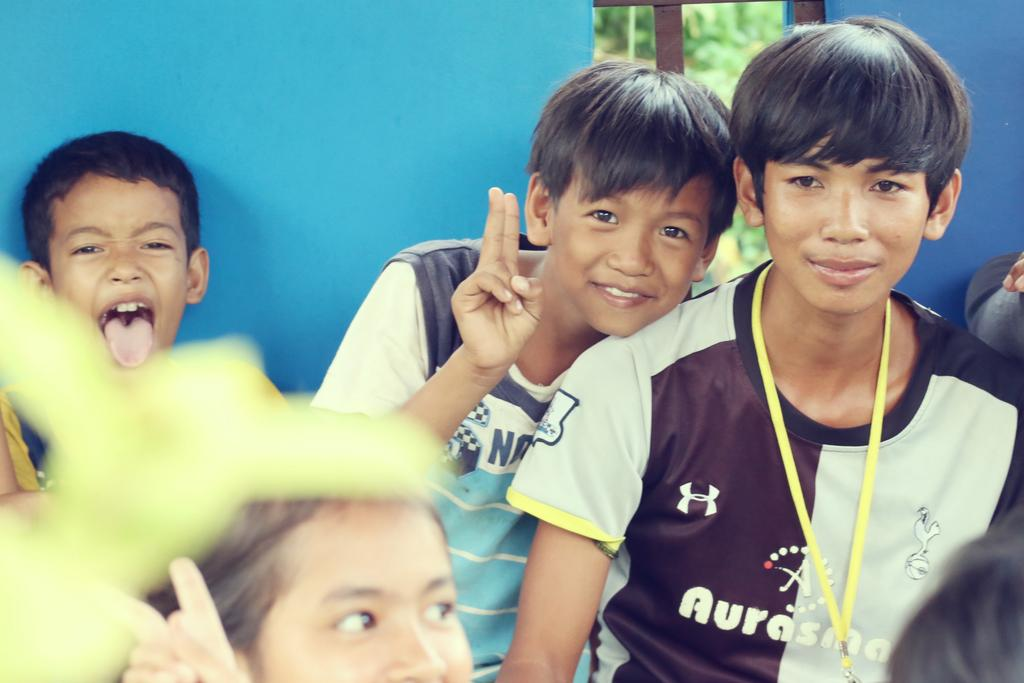<image>
Write a terse but informative summary of the picture. A kid wearing a purple and gray shirt that says Aurasma. 